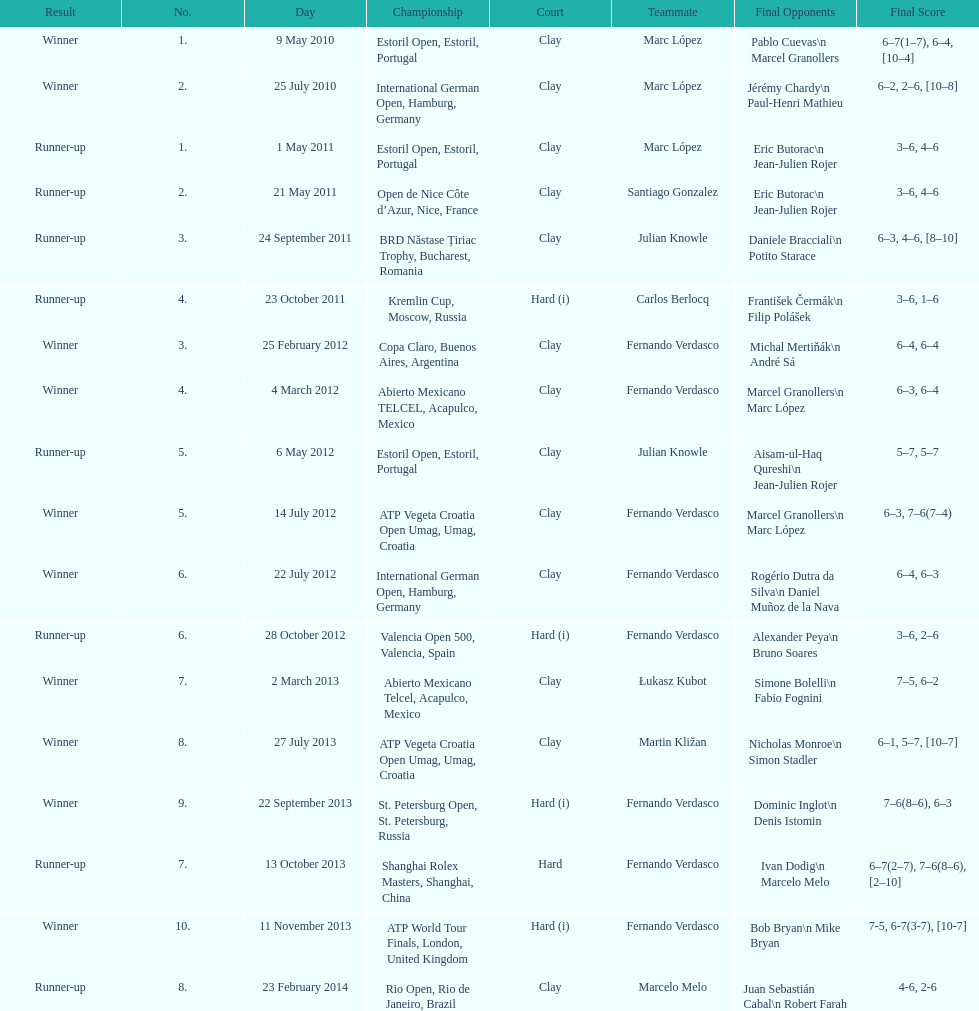What tournament was before the estoril open? Abierto Mexicano TELCEL, Acapulco, Mexico. 